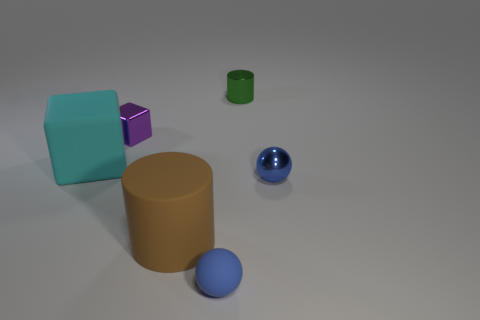How are the shadows in the image informing us about the light source? The shadows cast by the objects suggest that there is a single light source to the upper right of the scene. The shadows are relatively soft, indicating the light may not be extremely close to the objects. Can you infer the time of day in this scene? Given the controlled lighting and the lack of environmental context, it's likely this is an indoor scene and the time of day cannot be inferred from the image. 